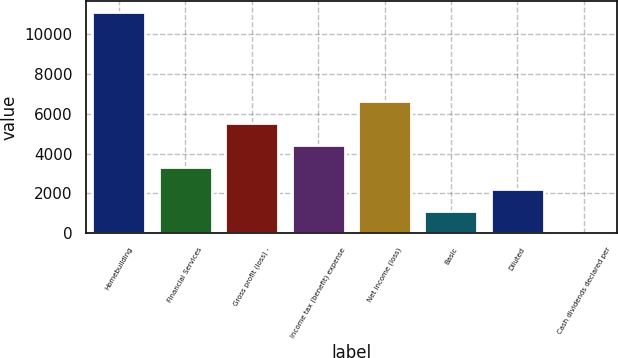<chart> <loc_0><loc_0><loc_500><loc_500><bar_chart><fcel>Homebuilding<fcel>Financial Services<fcel>Gross profit (loss) -<fcel>Income tax (benefit) expense<fcel>Net income (loss)<fcel>Basic<fcel>Diluted<fcel>Cash dividends declared per<nl><fcel>11088.8<fcel>3327.06<fcel>5544.7<fcel>4435.88<fcel>6653.52<fcel>1109.42<fcel>2218.24<fcel>0.6<nl></chart> 